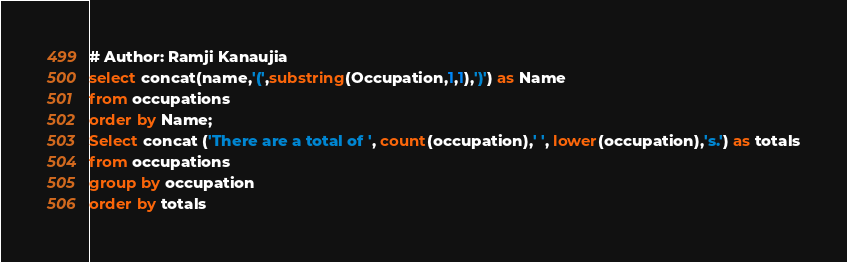Convert code to text. <code><loc_0><loc_0><loc_500><loc_500><_SQL_># Author: Ramji Kanaujia
select concat(name,'(',substring(Occupation,1,1),')') as Name 
from occupations 
order by Name;
Select concat ('There are a total of ', count(occupation),' ', lower(occupation),'s.') as totals
from occupations
group by occupation
order by totals</code> 